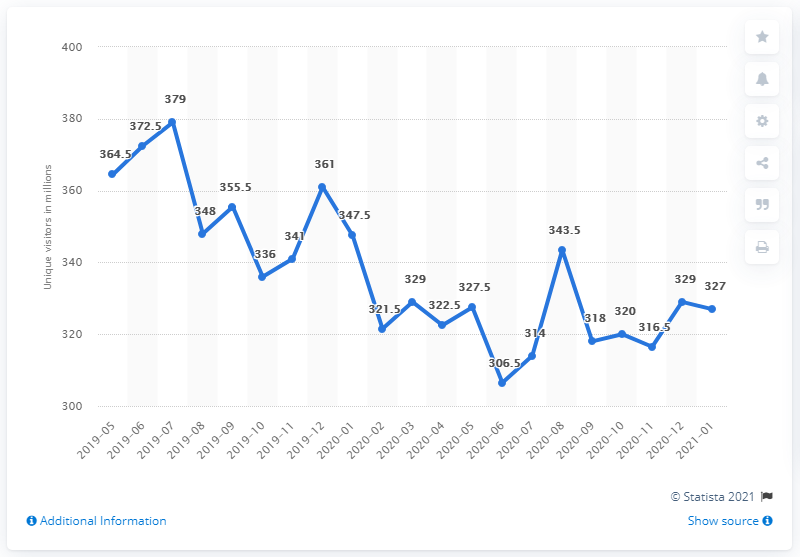Draw attention to some important aspects in this diagram. In January 2020, Tumblr had a total of 347.5 unique visitors. As of January 2021, Tumblr had 327 unique visitors. 